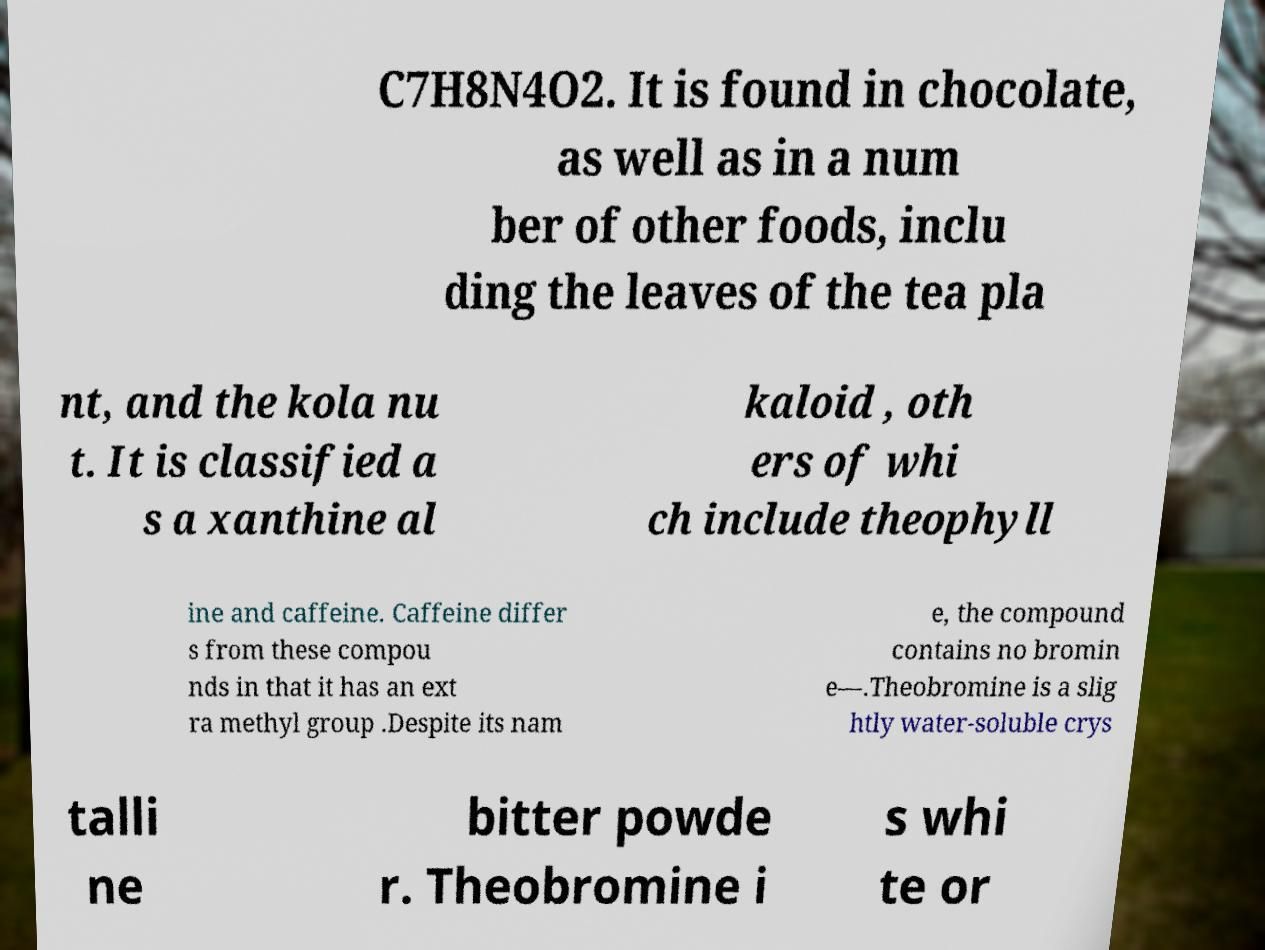For documentation purposes, I need the text within this image transcribed. Could you provide that? C7H8N4O2. It is found in chocolate, as well as in a num ber of other foods, inclu ding the leaves of the tea pla nt, and the kola nu t. It is classified a s a xanthine al kaloid , oth ers of whi ch include theophyll ine and caffeine. Caffeine differ s from these compou nds in that it has an ext ra methyl group .Despite its nam e, the compound contains no bromin e—.Theobromine is a slig htly water-soluble crys talli ne bitter powde r. Theobromine i s whi te or 